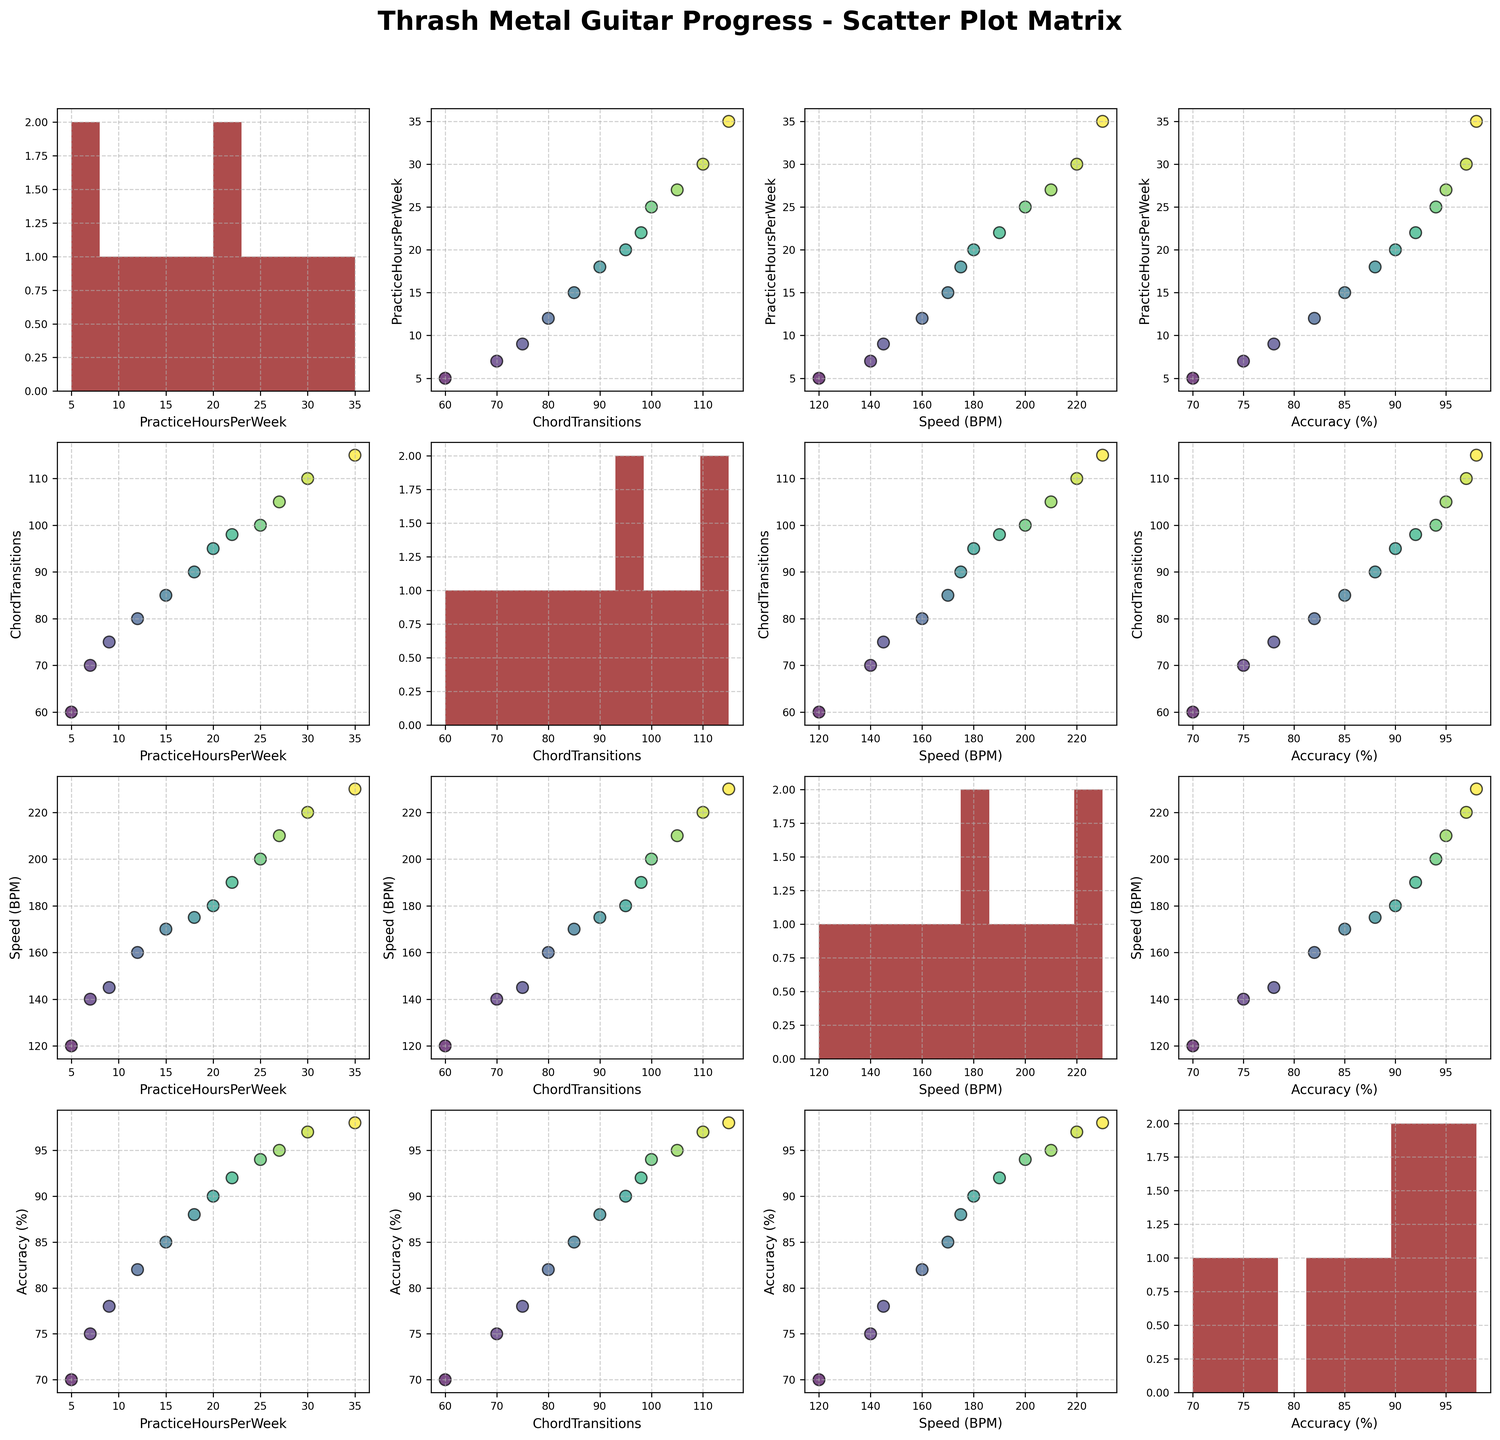What is the title of the figure? The figure's title is usually displayed at the top in a larger, bold font. In this case, it reads "Thrash Metal Guitar Progress - Scatter Plot Matrix."
Answer: Thrash Metal Guitar Progress - Scatter Plot Matrix What variables are plotted on the scatter plot matrix? The axes labels typically indicate the variables plotted. In this figure, the variables are 'PracticeHoursPerWeek', 'ChordTransitions', 'Speed (BPM)', and 'Accuracy (%).'
Answer: PracticeHoursPerWeek, ChordTransitions, Speed (BPM), Accuracy (%) How many bins are used in the histograms along the diagonal? The histograms along the diagonal represent the distribution of each variable individually. Observing their structure, it appears that each histogram is divided into 10 bins.
Answer: 10 Which variable appears to have the most consistent positive relationship with 'Accuracy (%)'? By examining the scatter plots involving 'Accuracy (%)', we look for the one with a positive trend. 'PracticeHoursPerWeek' shows a strong positive linear trend with 'Accuracy (%).'
Answer: PracticeHoursPerWeek What are the maximum and minimum values for 'PracticeHoursPerWeek'? The scatter plots and the histogram for 'PracticeHoursPerWeek' reveal the data points' spread. The minimum value is 5, and the maximum value is 35 hours per week.
Answer: Minimum: 5, Maximum: 35 Which months show an outstanding level of improvement? The data points with 'Outstanding' improvement are plotted at the higher end of the axes in some scatter plots, like 'PracticeHoursPerWeek' vs. 'ImprovementLevel'. Identifying the colors for these points shows that August, September, and October correspond to 'Outstanding.'
Answer: August, September, October Do 'ChordTransitions' and 'Speed (BPM)' correlate with each other, and how? To determine the correlation, we inspect the scatter plot between 'ChordTransitions' and 'Speed (BPM)'. The upward trend indicates a positive correlation. Several data points align in a roughly ascending manner.
Answer: Positive correlation What is the range of 'Accuracy (%)'? The histogram and scatter plots for 'Accuracy (%)' indicate the distribution. The minimum accuracy observed is 70%, and the maximum accuracy observed is 98%.
Answer: 70% to 98% Between 'ChordTransitions' and 'PracticeHoursPerWeek,' which one increases more consistently with each other based on the scatter plots? Comparing the scatter plots, 'PracticeHoursPerWeek' shows a more linear and consistent increase than 'ChordTransitions' when paired with other variables, indicating a more consistent growth trend.
Answer: PracticeHoursPerWeek 